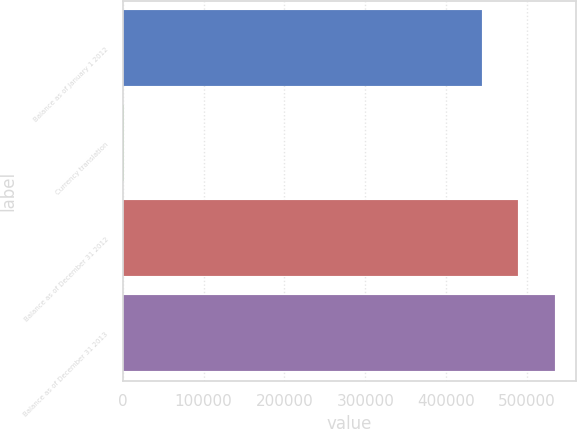Convert chart. <chart><loc_0><loc_0><loc_500><loc_500><bar_chart><fcel>Balance as of January 1 2012<fcel>Currency translation<fcel>Balance as of December 31 2012<fcel>Balance as of December 31 2013<nl><fcel>444431<fcel>1317<fcel>489249<fcel>534067<nl></chart> 